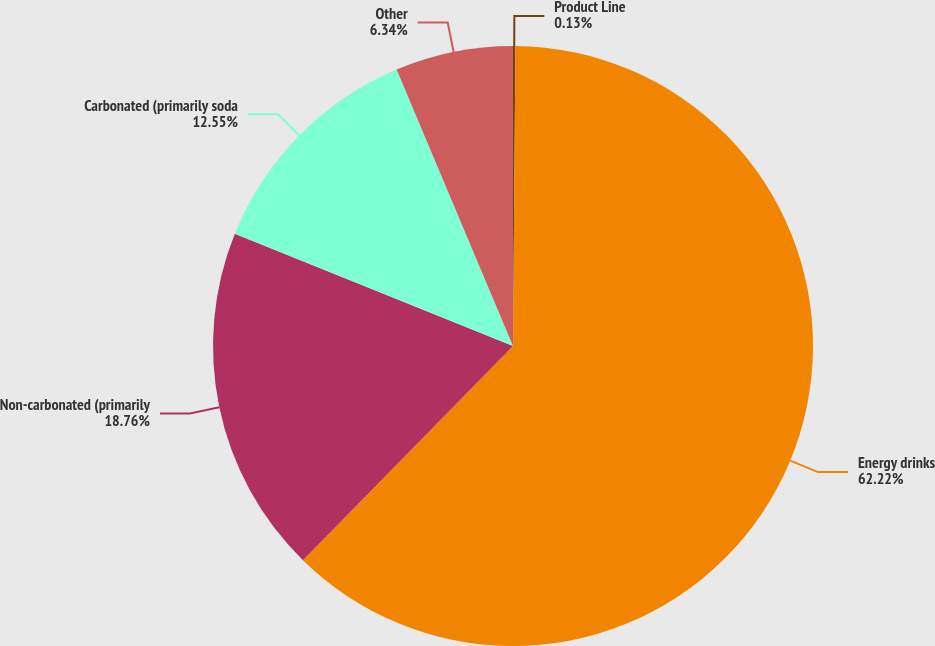Convert chart. <chart><loc_0><loc_0><loc_500><loc_500><pie_chart><fcel>Product Line<fcel>Energy drinks<fcel>Non-carbonated (primarily<fcel>Carbonated (primarily soda<fcel>Other<nl><fcel>0.13%<fcel>62.21%<fcel>18.76%<fcel>12.55%<fcel>6.34%<nl></chart> 